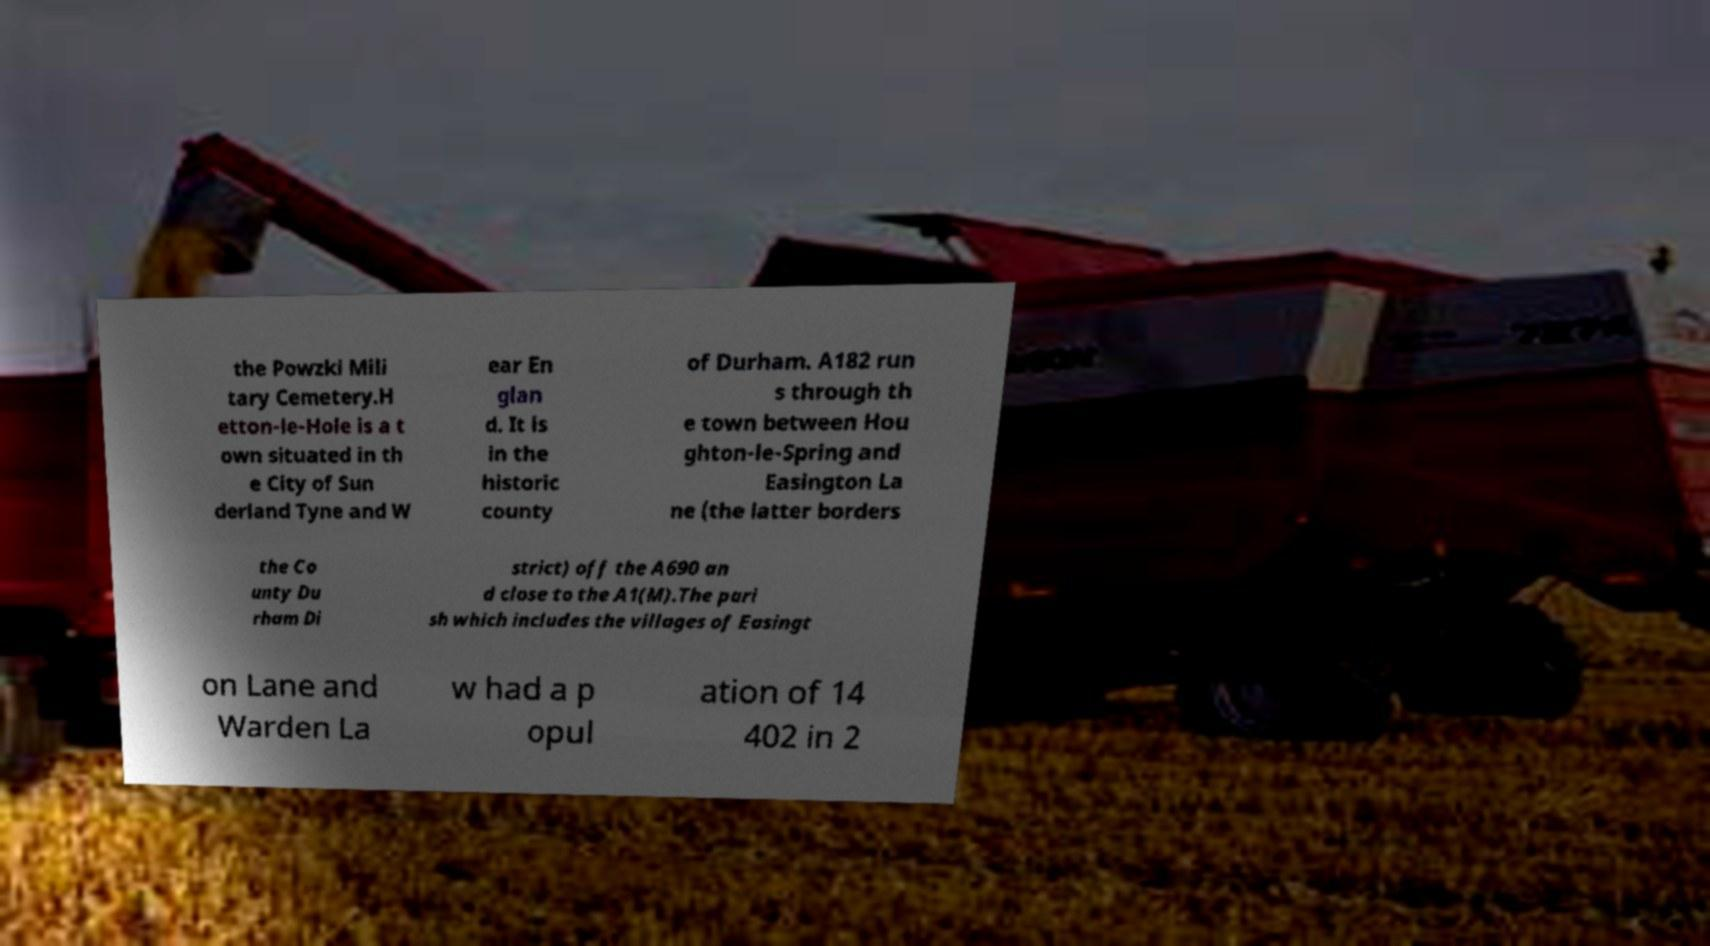For documentation purposes, I need the text within this image transcribed. Could you provide that? the Powzki Mili tary Cemetery.H etton-le-Hole is a t own situated in th e City of Sun derland Tyne and W ear En glan d. It is in the historic county of Durham. A182 run s through th e town between Hou ghton-le-Spring and Easington La ne (the latter borders the Co unty Du rham Di strict) off the A690 an d close to the A1(M).The pari sh which includes the villages of Easingt on Lane and Warden La w had a p opul ation of 14 402 in 2 